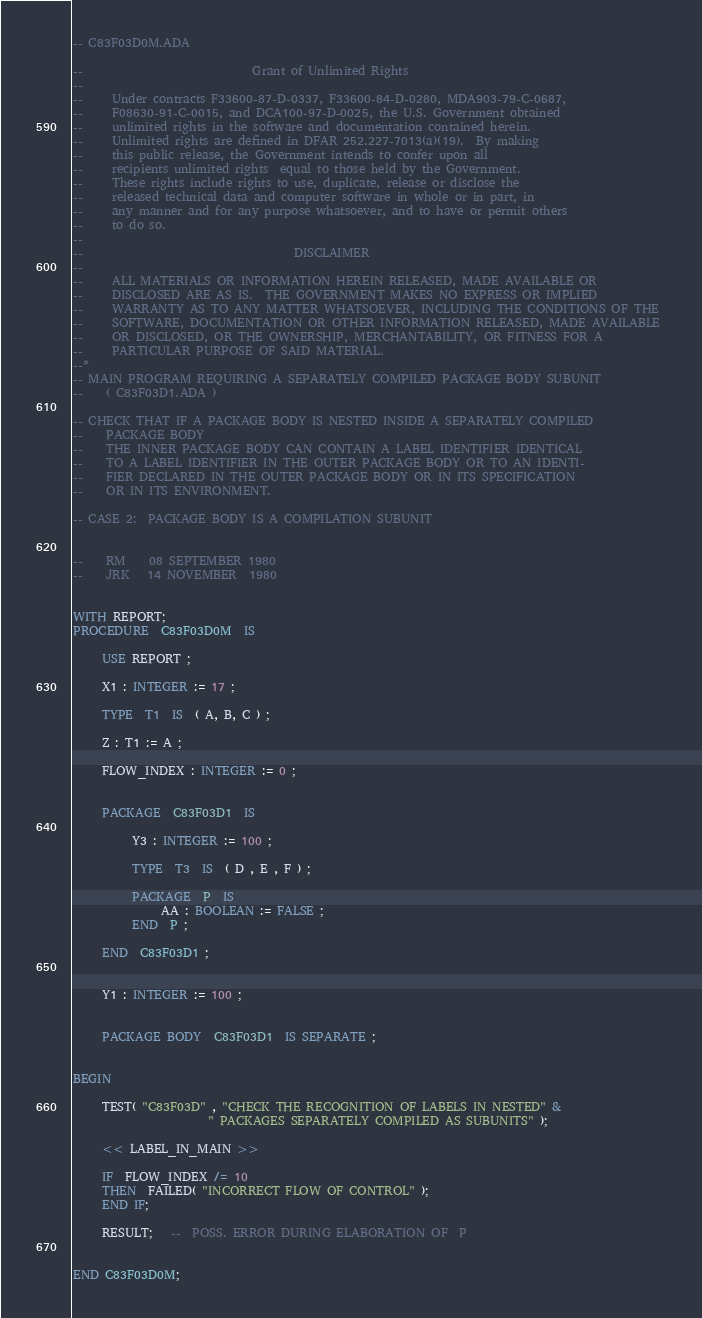<code> <loc_0><loc_0><loc_500><loc_500><_Ada_>-- C83F03D0M.ADA

--                             Grant of Unlimited Rights
--
--     Under contracts F33600-87-D-0337, F33600-84-D-0280, MDA903-79-C-0687,
--     F08630-91-C-0015, and DCA100-97-D-0025, the U.S. Government obtained 
--     unlimited rights in the software and documentation contained herein.
--     Unlimited rights are defined in DFAR 252.227-7013(a)(19).  By making 
--     this public release, the Government intends to confer upon all 
--     recipients unlimited rights  equal to those held by the Government.  
--     These rights include rights to use, duplicate, release or disclose the 
--     released technical data and computer software in whole or in part, in 
--     any manner and for any purpose whatsoever, and to have or permit others 
--     to do so.
--
--                                    DISCLAIMER
--
--     ALL MATERIALS OR INFORMATION HEREIN RELEASED, MADE AVAILABLE OR
--     DISCLOSED ARE AS IS.  THE GOVERNMENT MAKES NO EXPRESS OR IMPLIED 
--     WARRANTY AS TO ANY MATTER WHATSOEVER, INCLUDING THE CONDITIONS OF THE
--     SOFTWARE, DOCUMENTATION OR OTHER INFORMATION RELEASED, MADE AVAILABLE 
--     OR DISCLOSED, OR THE OWNERSHIP, MERCHANTABILITY, OR FITNESS FOR A
--     PARTICULAR PURPOSE OF SAID MATERIAL.
--*
-- MAIN PROGRAM REQUIRING A SEPARATELY COMPILED PACKAGE BODY SUBUNIT
--    ( C83F03D1.ADA )

-- CHECK THAT IF A PACKAGE BODY IS NESTED INSIDE A SEPARATELY COMPILED
--    PACKAGE BODY
--    THE INNER PACKAGE BODY CAN CONTAIN A LABEL IDENTIFIER IDENTICAL
--    TO A LABEL IDENTIFIER IN THE OUTER PACKAGE BODY OR TO AN IDENTI-
--    FIER DECLARED IN THE OUTER PACKAGE BODY OR IN ITS SPECIFICATION
--    OR IN ITS ENVIRONMENT.

-- CASE 2:  PACKAGE BODY IS A COMPILATION SUBUNIT


--    RM    08 SEPTEMBER 1980
--    JRK   14 NOVEMBER  1980


WITH REPORT;
PROCEDURE  C83F03D0M  IS

     USE REPORT ;

     X1 : INTEGER := 17 ;

     TYPE  T1  IS  ( A, B, C ) ;

     Z : T1 := A ;

     FLOW_INDEX : INTEGER := 0 ;


     PACKAGE  C83F03D1  IS

          Y3 : INTEGER := 100 ;

          TYPE  T3  IS  ( D , E , F ) ;

          PACKAGE  P  IS
               AA : BOOLEAN := FALSE ;
          END  P ;

     END  C83F03D1 ;


     Y1 : INTEGER := 100 ;


     PACKAGE BODY  C83F03D1  IS SEPARATE ;


BEGIN

     TEST( "C83F03D" , "CHECK THE RECOGNITION OF LABELS IN NESTED" &
                       " PACKAGES SEPARATELY COMPILED AS SUBUNITS" );

     << LABEL_IN_MAIN >>

     IF  FLOW_INDEX /= 10
     THEN  FAILED( "INCORRECT FLOW OF CONTROL" );
     END IF;

     RESULT;   --  POSS. ERROR DURING ELABORATION OF  P


END C83F03D0M;
</code> 